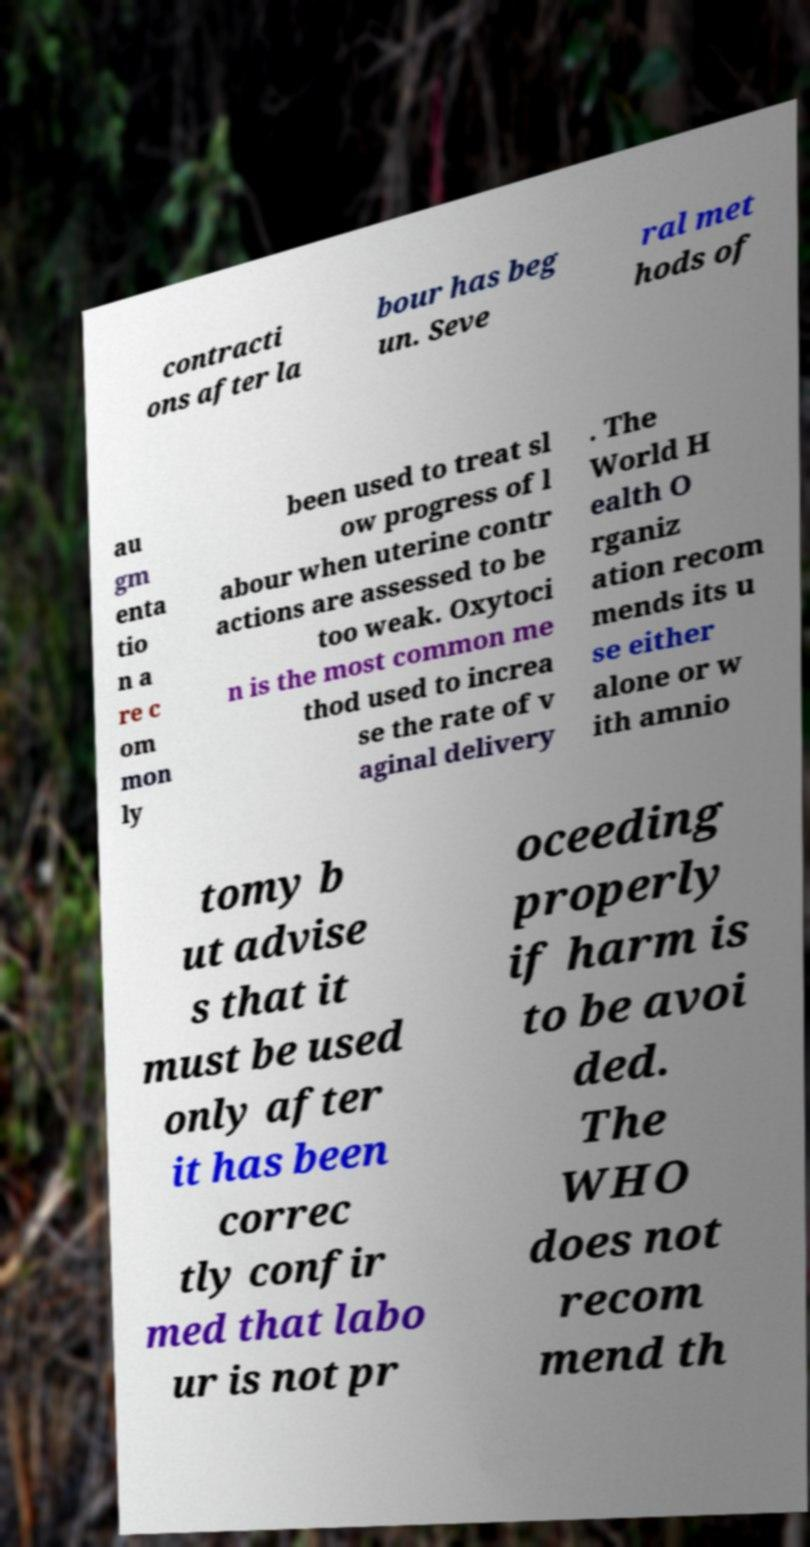I need the written content from this picture converted into text. Can you do that? contracti ons after la bour has beg un. Seve ral met hods of au gm enta tio n a re c om mon ly been used to treat sl ow progress of l abour when uterine contr actions are assessed to be too weak. Oxytoci n is the most common me thod used to increa se the rate of v aginal delivery . The World H ealth O rganiz ation recom mends its u se either alone or w ith amnio tomy b ut advise s that it must be used only after it has been correc tly confir med that labo ur is not pr oceeding properly if harm is to be avoi ded. The WHO does not recom mend th 